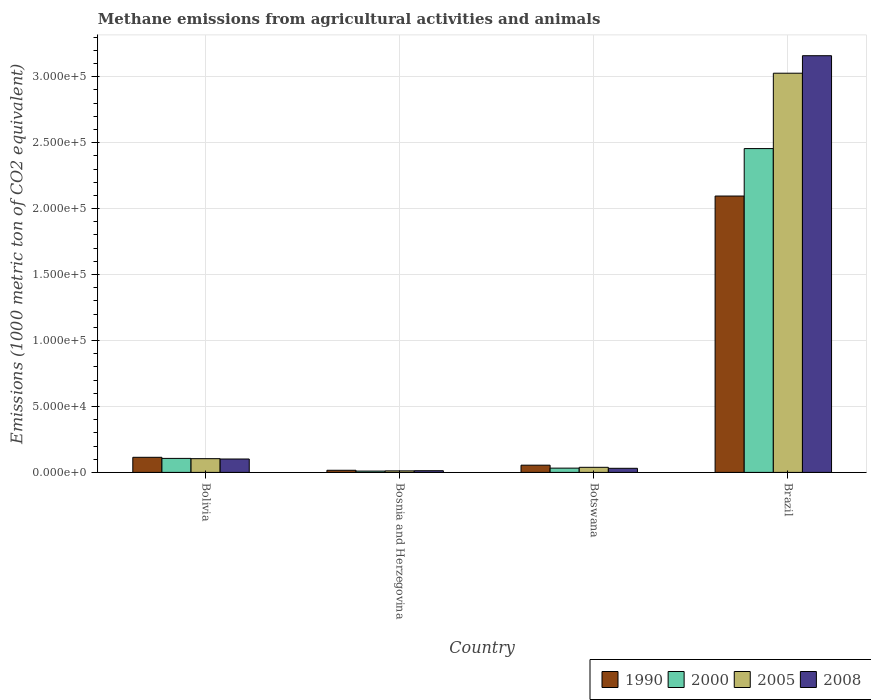How many groups of bars are there?
Make the answer very short. 4. Are the number of bars per tick equal to the number of legend labels?
Make the answer very short. Yes. Are the number of bars on each tick of the X-axis equal?
Make the answer very short. Yes. How many bars are there on the 2nd tick from the left?
Your answer should be compact. 4. What is the label of the 4th group of bars from the left?
Offer a terse response. Brazil. What is the amount of methane emitted in 2005 in Bolivia?
Your answer should be very brief. 1.04e+04. Across all countries, what is the maximum amount of methane emitted in 2008?
Provide a short and direct response. 3.16e+05. Across all countries, what is the minimum amount of methane emitted in 1990?
Your answer should be very brief. 1604.3. In which country was the amount of methane emitted in 1990 maximum?
Your response must be concise. Brazil. In which country was the amount of methane emitted in 2005 minimum?
Your answer should be compact. Bosnia and Herzegovina. What is the total amount of methane emitted in 1990 in the graph?
Make the answer very short. 2.28e+05. What is the difference between the amount of methane emitted in 2000 in Botswana and that in Brazil?
Keep it short and to the point. -2.42e+05. What is the difference between the amount of methane emitted in 2008 in Brazil and the amount of methane emitted in 1990 in Bolivia?
Offer a very short reply. 3.04e+05. What is the average amount of methane emitted in 2008 per country?
Provide a short and direct response. 8.26e+04. What is the difference between the amount of methane emitted of/in 1990 and amount of methane emitted of/in 2000 in Brazil?
Make the answer very short. -3.60e+04. In how many countries, is the amount of methane emitted in 2008 greater than 250000 1000 metric ton?
Offer a very short reply. 1. What is the ratio of the amount of methane emitted in 2005 in Botswana to that in Brazil?
Give a very brief answer. 0.01. What is the difference between the highest and the second highest amount of methane emitted in 2008?
Give a very brief answer. -7051.1. What is the difference between the highest and the lowest amount of methane emitted in 2005?
Provide a short and direct response. 3.01e+05. In how many countries, is the amount of methane emitted in 1990 greater than the average amount of methane emitted in 1990 taken over all countries?
Offer a very short reply. 1. Is it the case that in every country, the sum of the amount of methane emitted in 2008 and amount of methane emitted in 2000 is greater than the sum of amount of methane emitted in 2005 and amount of methane emitted in 1990?
Offer a very short reply. No. What does the 4th bar from the right in Botswana represents?
Your response must be concise. 1990. Is it the case that in every country, the sum of the amount of methane emitted in 2005 and amount of methane emitted in 2008 is greater than the amount of methane emitted in 2000?
Give a very brief answer. Yes. How many bars are there?
Give a very brief answer. 16. Are all the bars in the graph horizontal?
Ensure brevity in your answer.  No. Are the values on the major ticks of Y-axis written in scientific E-notation?
Your answer should be very brief. Yes. Does the graph contain grids?
Give a very brief answer. Yes. How many legend labels are there?
Provide a succinct answer. 4. How are the legend labels stacked?
Make the answer very short. Horizontal. What is the title of the graph?
Make the answer very short. Methane emissions from agricultural activities and animals. Does "1981" appear as one of the legend labels in the graph?
Offer a very short reply. No. What is the label or title of the Y-axis?
Provide a succinct answer. Emissions (1000 metric ton of CO2 equivalent). What is the Emissions (1000 metric ton of CO2 equivalent) in 1990 in Bolivia?
Your answer should be very brief. 1.14e+04. What is the Emissions (1000 metric ton of CO2 equivalent) in 2000 in Bolivia?
Your answer should be very brief. 1.06e+04. What is the Emissions (1000 metric ton of CO2 equivalent) in 2005 in Bolivia?
Offer a very short reply. 1.04e+04. What is the Emissions (1000 metric ton of CO2 equivalent) of 2008 in Bolivia?
Provide a short and direct response. 1.01e+04. What is the Emissions (1000 metric ton of CO2 equivalent) in 1990 in Bosnia and Herzegovina?
Your answer should be compact. 1604.3. What is the Emissions (1000 metric ton of CO2 equivalent) in 2000 in Bosnia and Herzegovina?
Keep it short and to the point. 996.6. What is the Emissions (1000 metric ton of CO2 equivalent) of 2005 in Bosnia and Herzegovina?
Make the answer very short. 1161.2. What is the Emissions (1000 metric ton of CO2 equivalent) of 2008 in Bosnia and Herzegovina?
Keep it short and to the point. 1279.4. What is the Emissions (1000 metric ton of CO2 equivalent) of 1990 in Botswana?
Ensure brevity in your answer.  5471.2. What is the Emissions (1000 metric ton of CO2 equivalent) in 2000 in Botswana?
Provide a succinct answer. 3234. What is the Emissions (1000 metric ton of CO2 equivalent) in 2005 in Botswana?
Provide a short and direct response. 3850.6. What is the Emissions (1000 metric ton of CO2 equivalent) of 2008 in Botswana?
Ensure brevity in your answer.  3096.4. What is the Emissions (1000 metric ton of CO2 equivalent) of 1990 in Brazil?
Offer a very short reply. 2.10e+05. What is the Emissions (1000 metric ton of CO2 equivalent) in 2000 in Brazil?
Your response must be concise. 2.45e+05. What is the Emissions (1000 metric ton of CO2 equivalent) of 2005 in Brazil?
Keep it short and to the point. 3.03e+05. What is the Emissions (1000 metric ton of CO2 equivalent) in 2008 in Brazil?
Make the answer very short. 3.16e+05. Across all countries, what is the maximum Emissions (1000 metric ton of CO2 equivalent) in 1990?
Make the answer very short. 2.10e+05. Across all countries, what is the maximum Emissions (1000 metric ton of CO2 equivalent) of 2000?
Your answer should be very brief. 2.45e+05. Across all countries, what is the maximum Emissions (1000 metric ton of CO2 equivalent) in 2005?
Ensure brevity in your answer.  3.03e+05. Across all countries, what is the maximum Emissions (1000 metric ton of CO2 equivalent) of 2008?
Give a very brief answer. 3.16e+05. Across all countries, what is the minimum Emissions (1000 metric ton of CO2 equivalent) in 1990?
Your answer should be very brief. 1604.3. Across all countries, what is the minimum Emissions (1000 metric ton of CO2 equivalent) of 2000?
Offer a very short reply. 996.6. Across all countries, what is the minimum Emissions (1000 metric ton of CO2 equivalent) of 2005?
Ensure brevity in your answer.  1161.2. Across all countries, what is the minimum Emissions (1000 metric ton of CO2 equivalent) in 2008?
Give a very brief answer. 1279.4. What is the total Emissions (1000 metric ton of CO2 equivalent) in 1990 in the graph?
Your answer should be compact. 2.28e+05. What is the total Emissions (1000 metric ton of CO2 equivalent) in 2000 in the graph?
Offer a terse response. 2.60e+05. What is the total Emissions (1000 metric ton of CO2 equivalent) in 2005 in the graph?
Make the answer very short. 3.18e+05. What is the total Emissions (1000 metric ton of CO2 equivalent) in 2008 in the graph?
Your response must be concise. 3.30e+05. What is the difference between the Emissions (1000 metric ton of CO2 equivalent) in 1990 in Bolivia and that in Bosnia and Herzegovina?
Give a very brief answer. 9840.7. What is the difference between the Emissions (1000 metric ton of CO2 equivalent) in 2000 in Bolivia and that in Bosnia and Herzegovina?
Your answer should be very brief. 9613.1. What is the difference between the Emissions (1000 metric ton of CO2 equivalent) of 2005 in Bolivia and that in Bosnia and Herzegovina?
Offer a very short reply. 9254.6. What is the difference between the Emissions (1000 metric ton of CO2 equivalent) of 2008 in Bolivia and that in Bosnia and Herzegovina?
Make the answer very short. 8868.1. What is the difference between the Emissions (1000 metric ton of CO2 equivalent) of 1990 in Bolivia and that in Botswana?
Give a very brief answer. 5973.8. What is the difference between the Emissions (1000 metric ton of CO2 equivalent) in 2000 in Bolivia and that in Botswana?
Give a very brief answer. 7375.7. What is the difference between the Emissions (1000 metric ton of CO2 equivalent) in 2005 in Bolivia and that in Botswana?
Your answer should be very brief. 6565.2. What is the difference between the Emissions (1000 metric ton of CO2 equivalent) of 2008 in Bolivia and that in Botswana?
Your response must be concise. 7051.1. What is the difference between the Emissions (1000 metric ton of CO2 equivalent) in 1990 in Bolivia and that in Brazil?
Give a very brief answer. -1.98e+05. What is the difference between the Emissions (1000 metric ton of CO2 equivalent) in 2000 in Bolivia and that in Brazil?
Your response must be concise. -2.35e+05. What is the difference between the Emissions (1000 metric ton of CO2 equivalent) in 2005 in Bolivia and that in Brazil?
Give a very brief answer. -2.92e+05. What is the difference between the Emissions (1000 metric ton of CO2 equivalent) in 2008 in Bolivia and that in Brazil?
Give a very brief answer. -3.06e+05. What is the difference between the Emissions (1000 metric ton of CO2 equivalent) of 1990 in Bosnia and Herzegovina and that in Botswana?
Make the answer very short. -3866.9. What is the difference between the Emissions (1000 metric ton of CO2 equivalent) of 2000 in Bosnia and Herzegovina and that in Botswana?
Make the answer very short. -2237.4. What is the difference between the Emissions (1000 metric ton of CO2 equivalent) in 2005 in Bosnia and Herzegovina and that in Botswana?
Your answer should be very brief. -2689.4. What is the difference between the Emissions (1000 metric ton of CO2 equivalent) in 2008 in Bosnia and Herzegovina and that in Botswana?
Your answer should be very brief. -1817. What is the difference between the Emissions (1000 metric ton of CO2 equivalent) in 1990 in Bosnia and Herzegovina and that in Brazil?
Give a very brief answer. -2.08e+05. What is the difference between the Emissions (1000 metric ton of CO2 equivalent) of 2000 in Bosnia and Herzegovina and that in Brazil?
Offer a terse response. -2.44e+05. What is the difference between the Emissions (1000 metric ton of CO2 equivalent) in 2005 in Bosnia and Herzegovina and that in Brazil?
Your answer should be compact. -3.01e+05. What is the difference between the Emissions (1000 metric ton of CO2 equivalent) in 2008 in Bosnia and Herzegovina and that in Brazil?
Your response must be concise. -3.15e+05. What is the difference between the Emissions (1000 metric ton of CO2 equivalent) in 1990 in Botswana and that in Brazil?
Your answer should be compact. -2.04e+05. What is the difference between the Emissions (1000 metric ton of CO2 equivalent) of 2000 in Botswana and that in Brazil?
Keep it short and to the point. -2.42e+05. What is the difference between the Emissions (1000 metric ton of CO2 equivalent) in 2005 in Botswana and that in Brazil?
Give a very brief answer. -2.99e+05. What is the difference between the Emissions (1000 metric ton of CO2 equivalent) of 2008 in Botswana and that in Brazil?
Your response must be concise. -3.13e+05. What is the difference between the Emissions (1000 metric ton of CO2 equivalent) of 1990 in Bolivia and the Emissions (1000 metric ton of CO2 equivalent) of 2000 in Bosnia and Herzegovina?
Your response must be concise. 1.04e+04. What is the difference between the Emissions (1000 metric ton of CO2 equivalent) in 1990 in Bolivia and the Emissions (1000 metric ton of CO2 equivalent) in 2005 in Bosnia and Herzegovina?
Make the answer very short. 1.03e+04. What is the difference between the Emissions (1000 metric ton of CO2 equivalent) of 1990 in Bolivia and the Emissions (1000 metric ton of CO2 equivalent) of 2008 in Bosnia and Herzegovina?
Your answer should be very brief. 1.02e+04. What is the difference between the Emissions (1000 metric ton of CO2 equivalent) in 2000 in Bolivia and the Emissions (1000 metric ton of CO2 equivalent) in 2005 in Bosnia and Herzegovina?
Your response must be concise. 9448.5. What is the difference between the Emissions (1000 metric ton of CO2 equivalent) in 2000 in Bolivia and the Emissions (1000 metric ton of CO2 equivalent) in 2008 in Bosnia and Herzegovina?
Make the answer very short. 9330.3. What is the difference between the Emissions (1000 metric ton of CO2 equivalent) in 2005 in Bolivia and the Emissions (1000 metric ton of CO2 equivalent) in 2008 in Bosnia and Herzegovina?
Offer a very short reply. 9136.4. What is the difference between the Emissions (1000 metric ton of CO2 equivalent) of 1990 in Bolivia and the Emissions (1000 metric ton of CO2 equivalent) of 2000 in Botswana?
Your response must be concise. 8211. What is the difference between the Emissions (1000 metric ton of CO2 equivalent) of 1990 in Bolivia and the Emissions (1000 metric ton of CO2 equivalent) of 2005 in Botswana?
Make the answer very short. 7594.4. What is the difference between the Emissions (1000 metric ton of CO2 equivalent) in 1990 in Bolivia and the Emissions (1000 metric ton of CO2 equivalent) in 2008 in Botswana?
Your answer should be compact. 8348.6. What is the difference between the Emissions (1000 metric ton of CO2 equivalent) of 2000 in Bolivia and the Emissions (1000 metric ton of CO2 equivalent) of 2005 in Botswana?
Keep it short and to the point. 6759.1. What is the difference between the Emissions (1000 metric ton of CO2 equivalent) in 2000 in Bolivia and the Emissions (1000 metric ton of CO2 equivalent) in 2008 in Botswana?
Provide a succinct answer. 7513.3. What is the difference between the Emissions (1000 metric ton of CO2 equivalent) in 2005 in Bolivia and the Emissions (1000 metric ton of CO2 equivalent) in 2008 in Botswana?
Provide a succinct answer. 7319.4. What is the difference between the Emissions (1000 metric ton of CO2 equivalent) in 1990 in Bolivia and the Emissions (1000 metric ton of CO2 equivalent) in 2000 in Brazil?
Make the answer very short. -2.34e+05. What is the difference between the Emissions (1000 metric ton of CO2 equivalent) of 1990 in Bolivia and the Emissions (1000 metric ton of CO2 equivalent) of 2005 in Brazil?
Your response must be concise. -2.91e+05. What is the difference between the Emissions (1000 metric ton of CO2 equivalent) of 1990 in Bolivia and the Emissions (1000 metric ton of CO2 equivalent) of 2008 in Brazil?
Offer a very short reply. -3.04e+05. What is the difference between the Emissions (1000 metric ton of CO2 equivalent) in 2000 in Bolivia and the Emissions (1000 metric ton of CO2 equivalent) in 2005 in Brazil?
Offer a very short reply. -2.92e+05. What is the difference between the Emissions (1000 metric ton of CO2 equivalent) of 2000 in Bolivia and the Emissions (1000 metric ton of CO2 equivalent) of 2008 in Brazil?
Offer a very short reply. -3.05e+05. What is the difference between the Emissions (1000 metric ton of CO2 equivalent) of 2005 in Bolivia and the Emissions (1000 metric ton of CO2 equivalent) of 2008 in Brazil?
Keep it short and to the point. -3.05e+05. What is the difference between the Emissions (1000 metric ton of CO2 equivalent) in 1990 in Bosnia and Herzegovina and the Emissions (1000 metric ton of CO2 equivalent) in 2000 in Botswana?
Offer a very short reply. -1629.7. What is the difference between the Emissions (1000 metric ton of CO2 equivalent) in 1990 in Bosnia and Herzegovina and the Emissions (1000 metric ton of CO2 equivalent) in 2005 in Botswana?
Keep it short and to the point. -2246.3. What is the difference between the Emissions (1000 metric ton of CO2 equivalent) of 1990 in Bosnia and Herzegovina and the Emissions (1000 metric ton of CO2 equivalent) of 2008 in Botswana?
Your answer should be very brief. -1492.1. What is the difference between the Emissions (1000 metric ton of CO2 equivalent) of 2000 in Bosnia and Herzegovina and the Emissions (1000 metric ton of CO2 equivalent) of 2005 in Botswana?
Your answer should be very brief. -2854. What is the difference between the Emissions (1000 metric ton of CO2 equivalent) of 2000 in Bosnia and Herzegovina and the Emissions (1000 metric ton of CO2 equivalent) of 2008 in Botswana?
Provide a succinct answer. -2099.8. What is the difference between the Emissions (1000 metric ton of CO2 equivalent) of 2005 in Bosnia and Herzegovina and the Emissions (1000 metric ton of CO2 equivalent) of 2008 in Botswana?
Make the answer very short. -1935.2. What is the difference between the Emissions (1000 metric ton of CO2 equivalent) of 1990 in Bosnia and Herzegovina and the Emissions (1000 metric ton of CO2 equivalent) of 2000 in Brazil?
Your answer should be very brief. -2.44e+05. What is the difference between the Emissions (1000 metric ton of CO2 equivalent) in 1990 in Bosnia and Herzegovina and the Emissions (1000 metric ton of CO2 equivalent) in 2005 in Brazil?
Your answer should be very brief. -3.01e+05. What is the difference between the Emissions (1000 metric ton of CO2 equivalent) of 1990 in Bosnia and Herzegovina and the Emissions (1000 metric ton of CO2 equivalent) of 2008 in Brazil?
Your answer should be very brief. -3.14e+05. What is the difference between the Emissions (1000 metric ton of CO2 equivalent) in 2000 in Bosnia and Herzegovina and the Emissions (1000 metric ton of CO2 equivalent) in 2005 in Brazil?
Your answer should be compact. -3.02e+05. What is the difference between the Emissions (1000 metric ton of CO2 equivalent) of 2000 in Bosnia and Herzegovina and the Emissions (1000 metric ton of CO2 equivalent) of 2008 in Brazil?
Provide a short and direct response. -3.15e+05. What is the difference between the Emissions (1000 metric ton of CO2 equivalent) in 2005 in Bosnia and Herzegovina and the Emissions (1000 metric ton of CO2 equivalent) in 2008 in Brazil?
Your response must be concise. -3.15e+05. What is the difference between the Emissions (1000 metric ton of CO2 equivalent) in 1990 in Botswana and the Emissions (1000 metric ton of CO2 equivalent) in 2000 in Brazil?
Provide a short and direct response. -2.40e+05. What is the difference between the Emissions (1000 metric ton of CO2 equivalent) in 1990 in Botswana and the Emissions (1000 metric ton of CO2 equivalent) in 2005 in Brazil?
Make the answer very short. -2.97e+05. What is the difference between the Emissions (1000 metric ton of CO2 equivalent) of 1990 in Botswana and the Emissions (1000 metric ton of CO2 equivalent) of 2008 in Brazil?
Provide a short and direct response. -3.10e+05. What is the difference between the Emissions (1000 metric ton of CO2 equivalent) in 2000 in Botswana and the Emissions (1000 metric ton of CO2 equivalent) in 2005 in Brazil?
Provide a succinct answer. -2.99e+05. What is the difference between the Emissions (1000 metric ton of CO2 equivalent) of 2000 in Botswana and the Emissions (1000 metric ton of CO2 equivalent) of 2008 in Brazil?
Provide a short and direct response. -3.13e+05. What is the difference between the Emissions (1000 metric ton of CO2 equivalent) of 2005 in Botswana and the Emissions (1000 metric ton of CO2 equivalent) of 2008 in Brazil?
Keep it short and to the point. -3.12e+05. What is the average Emissions (1000 metric ton of CO2 equivalent) in 1990 per country?
Keep it short and to the point. 5.70e+04. What is the average Emissions (1000 metric ton of CO2 equivalent) in 2000 per country?
Offer a very short reply. 6.51e+04. What is the average Emissions (1000 metric ton of CO2 equivalent) in 2005 per country?
Your response must be concise. 7.95e+04. What is the average Emissions (1000 metric ton of CO2 equivalent) in 2008 per country?
Your response must be concise. 8.26e+04. What is the difference between the Emissions (1000 metric ton of CO2 equivalent) in 1990 and Emissions (1000 metric ton of CO2 equivalent) in 2000 in Bolivia?
Offer a terse response. 835.3. What is the difference between the Emissions (1000 metric ton of CO2 equivalent) in 1990 and Emissions (1000 metric ton of CO2 equivalent) in 2005 in Bolivia?
Provide a succinct answer. 1029.2. What is the difference between the Emissions (1000 metric ton of CO2 equivalent) in 1990 and Emissions (1000 metric ton of CO2 equivalent) in 2008 in Bolivia?
Give a very brief answer. 1297.5. What is the difference between the Emissions (1000 metric ton of CO2 equivalent) in 2000 and Emissions (1000 metric ton of CO2 equivalent) in 2005 in Bolivia?
Offer a very short reply. 193.9. What is the difference between the Emissions (1000 metric ton of CO2 equivalent) of 2000 and Emissions (1000 metric ton of CO2 equivalent) of 2008 in Bolivia?
Offer a terse response. 462.2. What is the difference between the Emissions (1000 metric ton of CO2 equivalent) of 2005 and Emissions (1000 metric ton of CO2 equivalent) of 2008 in Bolivia?
Make the answer very short. 268.3. What is the difference between the Emissions (1000 metric ton of CO2 equivalent) in 1990 and Emissions (1000 metric ton of CO2 equivalent) in 2000 in Bosnia and Herzegovina?
Your answer should be compact. 607.7. What is the difference between the Emissions (1000 metric ton of CO2 equivalent) in 1990 and Emissions (1000 metric ton of CO2 equivalent) in 2005 in Bosnia and Herzegovina?
Offer a terse response. 443.1. What is the difference between the Emissions (1000 metric ton of CO2 equivalent) in 1990 and Emissions (1000 metric ton of CO2 equivalent) in 2008 in Bosnia and Herzegovina?
Ensure brevity in your answer.  324.9. What is the difference between the Emissions (1000 metric ton of CO2 equivalent) in 2000 and Emissions (1000 metric ton of CO2 equivalent) in 2005 in Bosnia and Herzegovina?
Keep it short and to the point. -164.6. What is the difference between the Emissions (1000 metric ton of CO2 equivalent) in 2000 and Emissions (1000 metric ton of CO2 equivalent) in 2008 in Bosnia and Herzegovina?
Provide a succinct answer. -282.8. What is the difference between the Emissions (1000 metric ton of CO2 equivalent) of 2005 and Emissions (1000 metric ton of CO2 equivalent) of 2008 in Bosnia and Herzegovina?
Offer a very short reply. -118.2. What is the difference between the Emissions (1000 metric ton of CO2 equivalent) in 1990 and Emissions (1000 metric ton of CO2 equivalent) in 2000 in Botswana?
Offer a terse response. 2237.2. What is the difference between the Emissions (1000 metric ton of CO2 equivalent) in 1990 and Emissions (1000 metric ton of CO2 equivalent) in 2005 in Botswana?
Provide a short and direct response. 1620.6. What is the difference between the Emissions (1000 metric ton of CO2 equivalent) in 1990 and Emissions (1000 metric ton of CO2 equivalent) in 2008 in Botswana?
Ensure brevity in your answer.  2374.8. What is the difference between the Emissions (1000 metric ton of CO2 equivalent) in 2000 and Emissions (1000 metric ton of CO2 equivalent) in 2005 in Botswana?
Offer a terse response. -616.6. What is the difference between the Emissions (1000 metric ton of CO2 equivalent) of 2000 and Emissions (1000 metric ton of CO2 equivalent) of 2008 in Botswana?
Your response must be concise. 137.6. What is the difference between the Emissions (1000 metric ton of CO2 equivalent) of 2005 and Emissions (1000 metric ton of CO2 equivalent) of 2008 in Botswana?
Keep it short and to the point. 754.2. What is the difference between the Emissions (1000 metric ton of CO2 equivalent) of 1990 and Emissions (1000 metric ton of CO2 equivalent) of 2000 in Brazil?
Keep it short and to the point. -3.60e+04. What is the difference between the Emissions (1000 metric ton of CO2 equivalent) in 1990 and Emissions (1000 metric ton of CO2 equivalent) in 2005 in Brazil?
Offer a terse response. -9.31e+04. What is the difference between the Emissions (1000 metric ton of CO2 equivalent) in 1990 and Emissions (1000 metric ton of CO2 equivalent) in 2008 in Brazil?
Offer a terse response. -1.06e+05. What is the difference between the Emissions (1000 metric ton of CO2 equivalent) in 2000 and Emissions (1000 metric ton of CO2 equivalent) in 2005 in Brazil?
Keep it short and to the point. -5.71e+04. What is the difference between the Emissions (1000 metric ton of CO2 equivalent) in 2000 and Emissions (1000 metric ton of CO2 equivalent) in 2008 in Brazil?
Offer a terse response. -7.04e+04. What is the difference between the Emissions (1000 metric ton of CO2 equivalent) of 2005 and Emissions (1000 metric ton of CO2 equivalent) of 2008 in Brazil?
Your answer should be compact. -1.33e+04. What is the ratio of the Emissions (1000 metric ton of CO2 equivalent) in 1990 in Bolivia to that in Bosnia and Herzegovina?
Ensure brevity in your answer.  7.13. What is the ratio of the Emissions (1000 metric ton of CO2 equivalent) in 2000 in Bolivia to that in Bosnia and Herzegovina?
Ensure brevity in your answer.  10.65. What is the ratio of the Emissions (1000 metric ton of CO2 equivalent) of 2005 in Bolivia to that in Bosnia and Herzegovina?
Your response must be concise. 8.97. What is the ratio of the Emissions (1000 metric ton of CO2 equivalent) in 2008 in Bolivia to that in Bosnia and Herzegovina?
Keep it short and to the point. 7.93. What is the ratio of the Emissions (1000 metric ton of CO2 equivalent) of 1990 in Bolivia to that in Botswana?
Offer a terse response. 2.09. What is the ratio of the Emissions (1000 metric ton of CO2 equivalent) in 2000 in Bolivia to that in Botswana?
Your answer should be compact. 3.28. What is the ratio of the Emissions (1000 metric ton of CO2 equivalent) of 2005 in Bolivia to that in Botswana?
Offer a terse response. 2.71. What is the ratio of the Emissions (1000 metric ton of CO2 equivalent) of 2008 in Bolivia to that in Botswana?
Offer a very short reply. 3.28. What is the ratio of the Emissions (1000 metric ton of CO2 equivalent) of 1990 in Bolivia to that in Brazil?
Provide a succinct answer. 0.05. What is the ratio of the Emissions (1000 metric ton of CO2 equivalent) in 2000 in Bolivia to that in Brazil?
Offer a very short reply. 0.04. What is the ratio of the Emissions (1000 metric ton of CO2 equivalent) of 2005 in Bolivia to that in Brazil?
Provide a succinct answer. 0.03. What is the ratio of the Emissions (1000 metric ton of CO2 equivalent) of 2008 in Bolivia to that in Brazil?
Ensure brevity in your answer.  0.03. What is the ratio of the Emissions (1000 metric ton of CO2 equivalent) in 1990 in Bosnia and Herzegovina to that in Botswana?
Offer a terse response. 0.29. What is the ratio of the Emissions (1000 metric ton of CO2 equivalent) of 2000 in Bosnia and Herzegovina to that in Botswana?
Give a very brief answer. 0.31. What is the ratio of the Emissions (1000 metric ton of CO2 equivalent) of 2005 in Bosnia and Herzegovina to that in Botswana?
Your answer should be compact. 0.3. What is the ratio of the Emissions (1000 metric ton of CO2 equivalent) of 2008 in Bosnia and Herzegovina to that in Botswana?
Provide a short and direct response. 0.41. What is the ratio of the Emissions (1000 metric ton of CO2 equivalent) of 1990 in Bosnia and Herzegovina to that in Brazil?
Make the answer very short. 0.01. What is the ratio of the Emissions (1000 metric ton of CO2 equivalent) of 2000 in Bosnia and Herzegovina to that in Brazil?
Provide a succinct answer. 0. What is the ratio of the Emissions (1000 metric ton of CO2 equivalent) in 2005 in Bosnia and Herzegovina to that in Brazil?
Your answer should be very brief. 0. What is the ratio of the Emissions (1000 metric ton of CO2 equivalent) of 2008 in Bosnia and Herzegovina to that in Brazil?
Make the answer very short. 0. What is the ratio of the Emissions (1000 metric ton of CO2 equivalent) in 1990 in Botswana to that in Brazil?
Provide a succinct answer. 0.03. What is the ratio of the Emissions (1000 metric ton of CO2 equivalent) of 2000 in Botswana to that in Brazil?
Your response must be concise. 0.01. What is the ratio of the Emissions (1000 metric ton of CO2 equivalent) in 2005 in Botswana to that in Brazil?
Give a very brief answer. 0.01. What is the ratio of the Emissions (1000 metric ton of CO2 equivalent) in 2008 in Botswana to that in Brazil?
Keep it short and to the point. 0.01. What is the difference between the highest and the second highest Emissions (1000 metric ton of CO2 equivalent) of 1990?
Keep it short and to the point. 1.98e+05. What is the difference between the highest and the second highest Emissions (1000 metric ton of CO2 equivalent) of 2000?
Your answer should be very brief. 2.35e+05. What is the difference between the highest and the second highest Emissions (1000 metric ton of CO2 equivalent) in 2005?
Make the answer very short. 2.92e+05. What is the difference between the highest and the second highest Emissions (1000 metric ton of CO2 equivalent) in 2008?
Offer a terse response. 3.06e+05. What is the difference between the highest and the lowest Emissions (1000 metric ton of CO2 equivalent) of 1990?
Your answer should be compact. 2.08e+05. What is the difference between the highest and the lowest Emissions (1000 metric ton of CO2 equivalent) in 2000?
Offer a very short reply. 2.44e+05. What is the difference between the highest and the lowest Emissions (1000 metric ton of CO2 equivalent) of 2005?
Keep it short and to the point. 3.01e+05. What is the difference between the highest and the lowest Emissions (1000 metric ton of CO2 equivalent) in 2008?
Make the answer very short. 3.15e+05. 